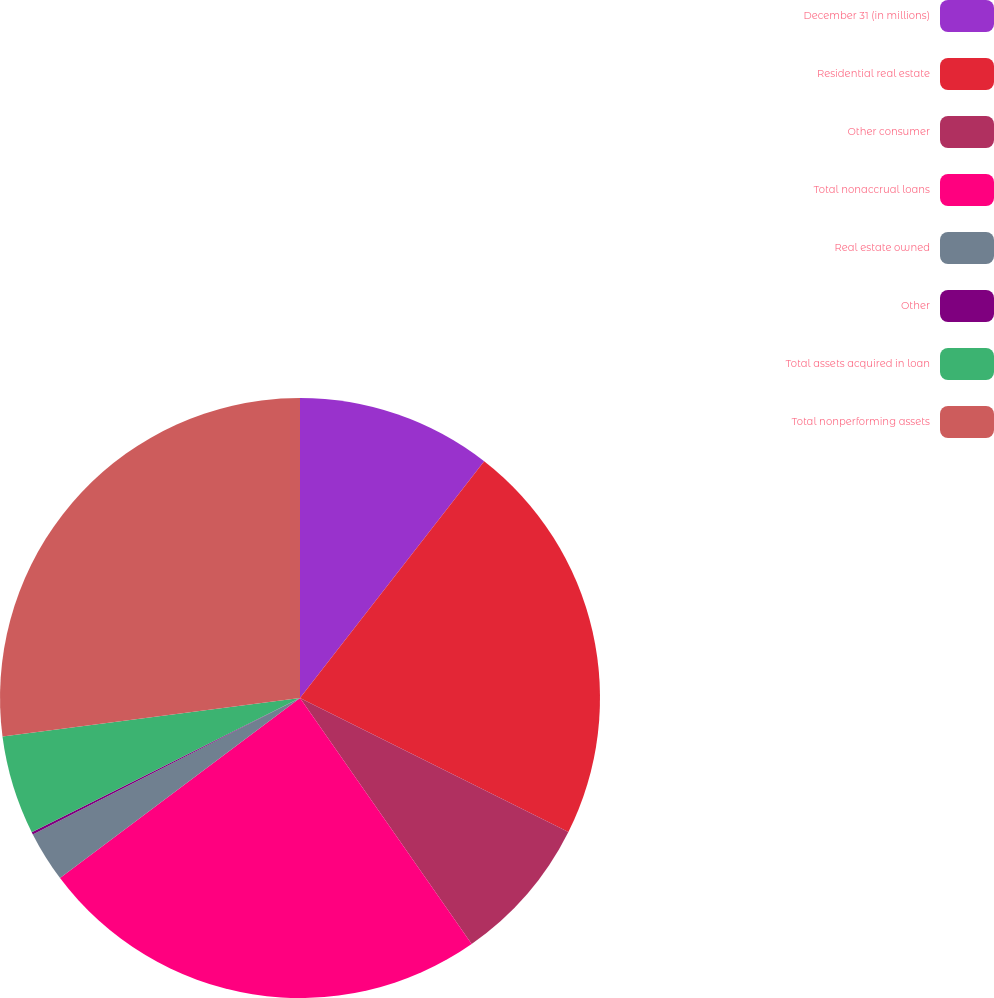<chart> <loc_0><loc_0><loc_500><loc_500><pie_chart><fcel>December 31 (in millions)<fcel>Residential real estate<fcel>Other consumer<fcel>Total nonaccrual loans<fcel>Real estate owned<fcel>Other<fcel>Total assets acquired in loan<fcel>Total nonperforming assets<nl><fcel>10.52%<fcel>21.85%<fcel>7.93%<fcel>24.45%<fcel>2.73%<fcel>0.13%<fcel>5.33%<fcel>27.05%<nl></chart> 